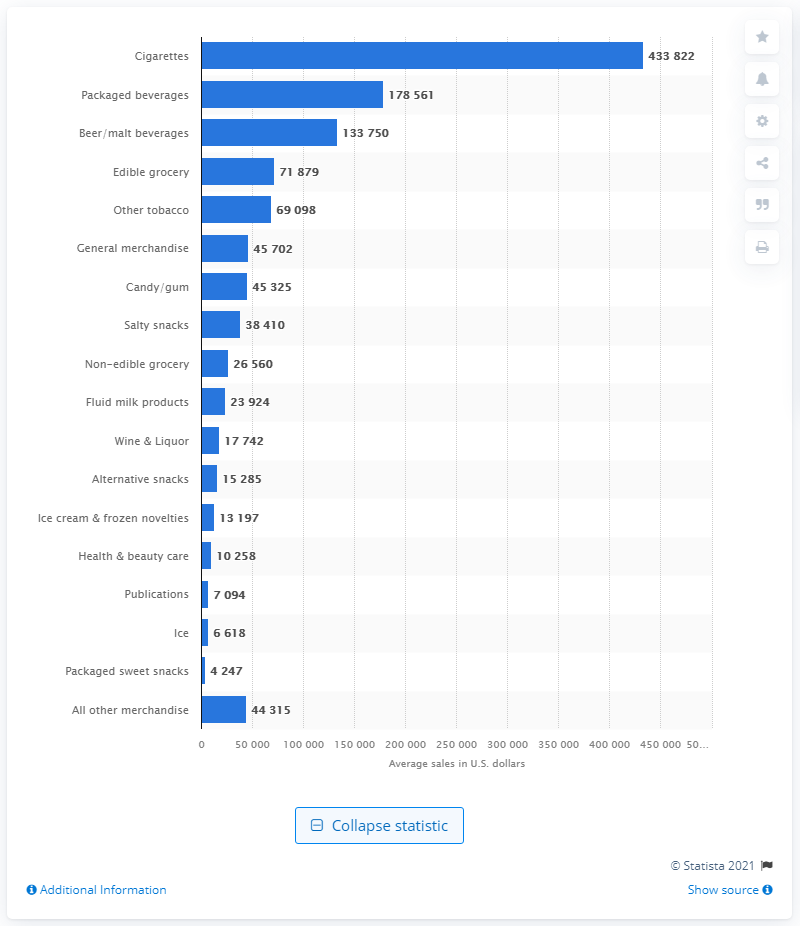Indicate a few pertinent items in this graphic. In the United States in 2015, cigarettes generated approximately 433,822 dollars. 